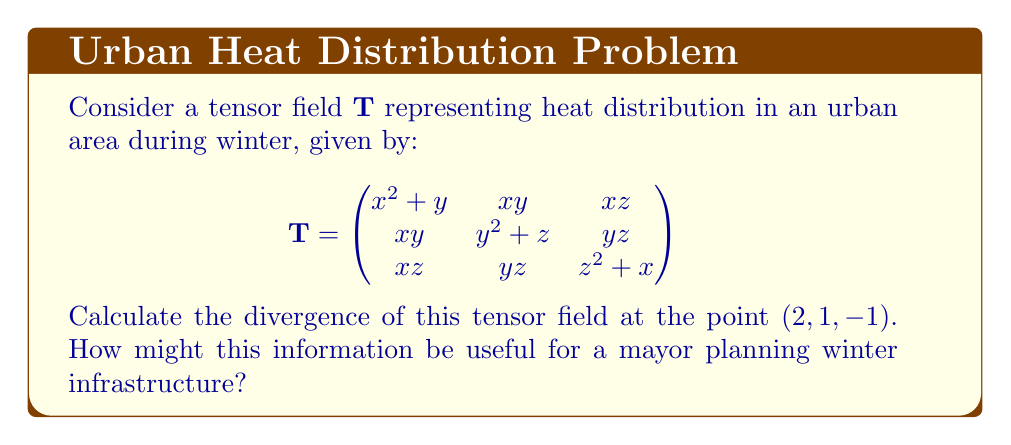Provide a solution to this math problem. To calculate the divergence of a tensor field, we need to sum the partial derivatives of the diagonal elements with respect to their corresponding variables:

$$\text{div}\mathbf{T} = \frac{\partial T_{11}}{\partial x} + \frac{\partial T_{22}}{\partial y} + \frac{\partial T_{33}}{\partial z}$$

Let's calculate each term:

1) $\frac{\partial T_{11}}{\partial x} = \frac{\partial}{\partial x}(x^2 + y) = 2x$

2) $\frac{\partial T_{22}}{\partial y} = \frac{\partial}{\partial y}(y^2 + z) = 2y$

3) $\frac{\partial T_{33}}{\partial z} = \frac{\partial}{\partial z}(z^2 + x) = 2z$

Now, we sum these terms:

$$\text{div}\mathbf{T} = 2x + 2y + 2z$$

Evaluating at the point $(2, 1, -1)$:

$$\text{div}\mathbf{T}(2, 1, -1) = 2(2) + 2(1) + 2(-1) = 4 + 2 - 2 = 4$$

This positive divergence indicates a net outflow of heat at this point. For a mayor, this information could be crucial in identifying areas of heat loss in the city during winter. It could guide decisions on where to focus insulation efforts, plan for additional heating infrastructure, or implement energy-saving measures to retain heat in these areas.
Answer: $4$ 